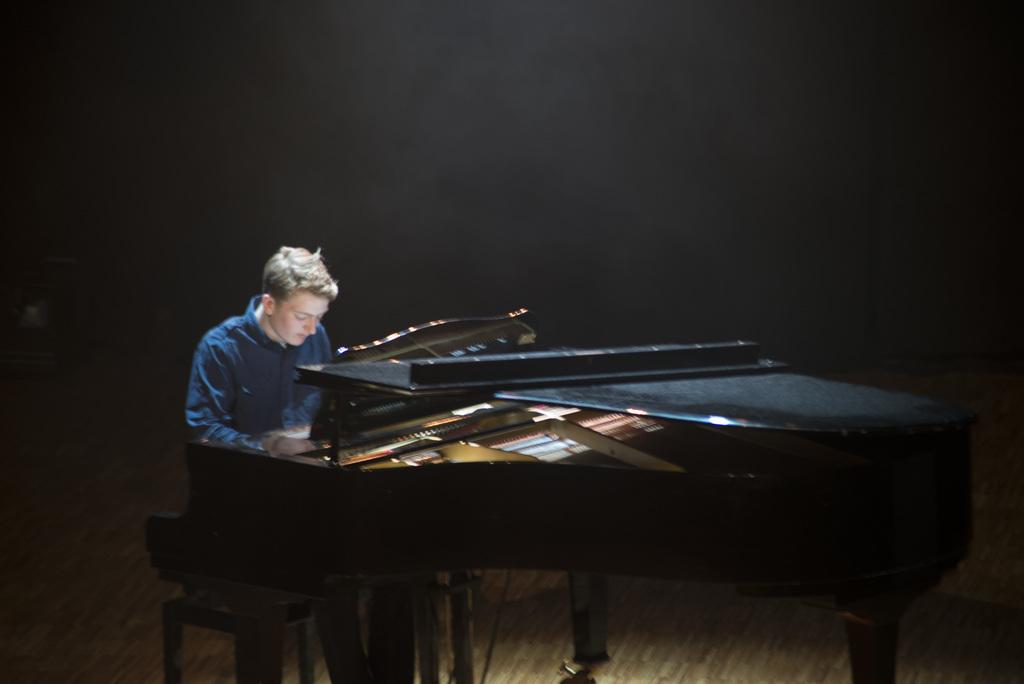What type of musical instrument is in the image? There is a black color piano in the image. Where is the piano located in the image? The piano is on the right side of the image. What is the person in the image doing? The person is sitting on a chair and playing the piano. What color is the wall in the background of the image? The wall in the background of the image is black color. What type of advertisement can be seen on the piano in the image? There is no advertisement present on the piano in the image; it is a black color piano with a person playing it. How does the person's behavior change when they see the advertisement on the piano? There is no advertisement on the piano, so the person's behavior does not change in response to it. 